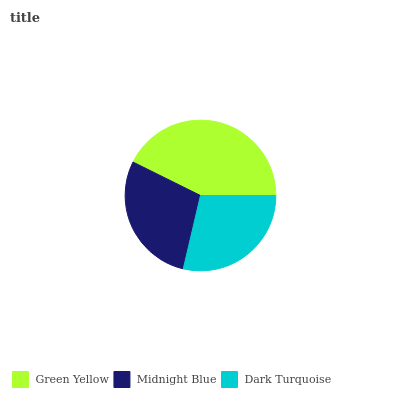Is Midnight Blue the minimum?
Answer yes or no. Yes. Is Green Yellow the maximum?
Answer yes or no. Yes. Is Dark Turquoise the minimum?
Answer yes or no. No. Is Dark Turquoise the maximum?
Answer yes or no. No. Is Dark Turquoise greater than Midnight Blue?
Answer yes or no. Yes. Is Midnight Blue less than Dark Turquoise?
Answer yes or no. Yes. Is Midnight Blue greater than Dark Turquoise?
Answer yes or no. No. Is Dark Turquoise less than Midnight Blue?
Answer yes or no. No. Is Dark Turquoise the high median?
Answer yes or no. Yes. Is Dark Turquoise the low median?
Answer yes or no. Yes. Is Green Yellow the high median?
Answer yes or no. No. Is Green Yellow the low median?
Answer yes or no. No. 